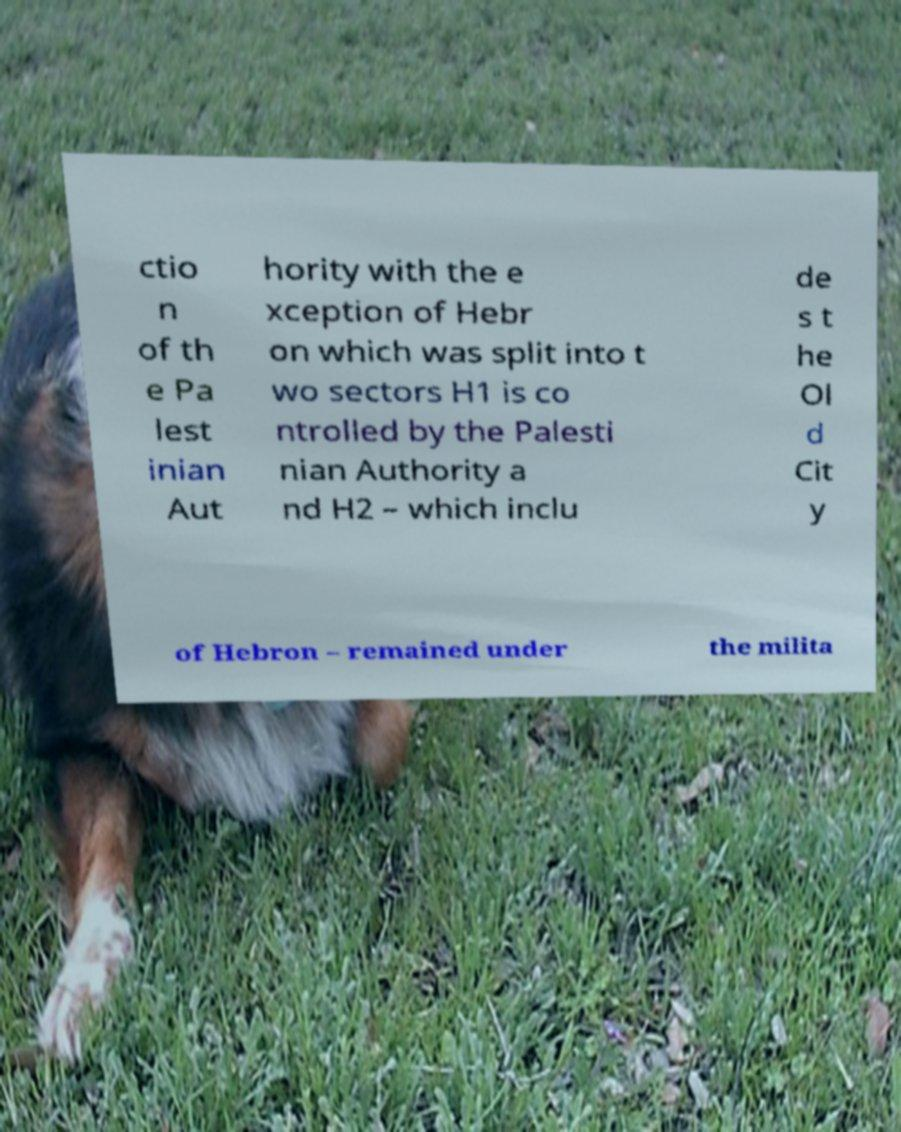For documentation purposes, I need the text within this image transcribed. Could you provide that? ctio n of th e Pa lest inian Aut hority with the e xception of Hebr on which was split into t wo sectors H1 is co ntrolled by the Palesti nian Authority a nd H2 – which inclu de s t he Ol d Cit y of Hebron – remained under the milita 